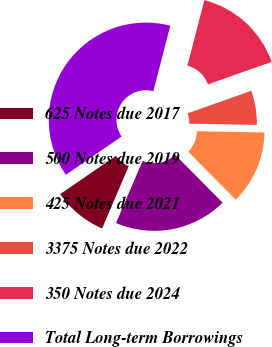Convert chart. <chart><loc_0><loc_0><loc_500><loc_500><pie_chart><fcel>625 Notes due 2017<fcel>500 Notes due 2019<fcel>425 Notes due 2021<fcel>3375 Notes due 2022<fcel>350 Notes due 2024<fcel>Total Long-term Borrowings<nl><fcel>8.99%<fcel>18.86%<fcel>12.28%<fcel>5.69%<fcel>15.57%<fcel>38.61%<nl></chart> 